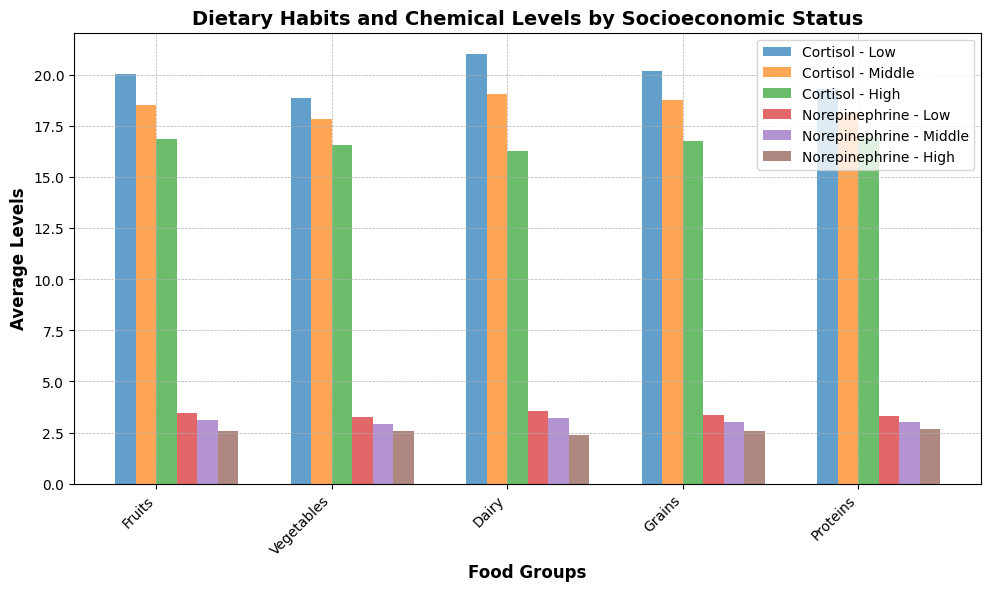What is the average Cortisol level for the Low SES group? First, look at the Cortisol levels for each food group in the Low SES category. Then, sum these Cortisol levels (18.8 + 19.3 + 19.7 + 20.5 + 21.5 + 19.2 + 19.1 + 20.1 + 19.8 + 21.0). Finally, divide by the number of data points (10) in this Low SES category.
Answer: 19.7 Which SES group has the highest average Norepinephrine levels for the Proteins food group? Look at the Norepinephrine levels for the Proteins food group across each SES category. Compare the values: Low (3.2, 3.5, 3.4), Middle (3.0, 3.1, 2.9), High (2.8, 2.5, 2.4). Observe that the highest values are in the Low SES category.
Answer: Low For the Fruits food group, does the High SES group have higher or lower Norepinephrine levels compared to the Middle SES group? Observe the Norepinephrine levels for Fruits in both High and Middle SES groups. Compare the values: High (2.4, 2.5, 2.8), Middle (2.9, 3.0). Notice that the levels in the High SES group are lower.
Answer: Lower Which food group shows the largest difference in average Cortisol levels between Low and High SES groups? Calculate the average Cortisol levels for each food group in both Low and High SES categories. Then, find the absolute differences: 
  Fruits Low (19.1) vs High (16.2) = 2.9, 
  Vegetables Low (19.5) vs High (17.0) = 2.5, 
  Dairy Low (20.0) vs High (16.9) = 3.1, 
  Grains Low (21.0) vs High (16.3) = 4.7, 
  Proteins Low (20.2) vs High (17.1) = 3.1. The largest difference is for Grains.
Answer: Grains As the socioeconomic status increases, what trend can be observed with respect to Cortisol levels in the Vegetables food group? Observe the average Cortisol levels in the Vegetables food group across Low, Middle, and High SES categories: Low (19.5), Middle (17.9), High (16.9). Notice that Cortisol levels decrease as socioeconomic status increases.
Answer: Decreasing What is the total number of bars presented for each SES group in the plot (consider both cortisol and norepinephrine)? There are 5 food groups for each SES. Each food group has two bars (one for Cortisol and one for Norepinephrine). Multiply the number of food groups by the number of bars per food group, and then further by each SES (5 * 2 * 3 = 30).
Answer: 10 Which food group in the High SES category has the lowest average Cortisol level? Observe the average Cortisol levels for each food group in the High SES category and identify the lowest value: Fruits (16.2), Vegetables (16.9), Dairy (16.5), Grains (16.3), Proteins (16.8). The lowest is Grains (16.0).
Answer: Grains For the Dairy food group, by how much does the average Norepinephrine level differ between Middle and High SES groups? Check the average Norepinephrine levels for Dairy in the Middle and High SES categories: Middle (3.1), High (2.7). Calculate the difference (3.1 - 2.7 = 0.4).
Answer: 0.4 Compare the average Cortisol level for the Low SES group with the High SES group across all food groups. Which group shows higher levels? Calculate the average Cortisol level for each SES group across all food groups. Observe that the average values for Low SES (19.7) are higher compared to High SES (16.9).
Answer: Low In the Grains food group, which SES group has the highest Norepinephrine level? Observe the Norepinephrine levels for Grains in each SES category: Low (3.6), Middle (3.2), High (2.4). The highest Norepinephrine level is in the Low SES group.
Answer: Low 